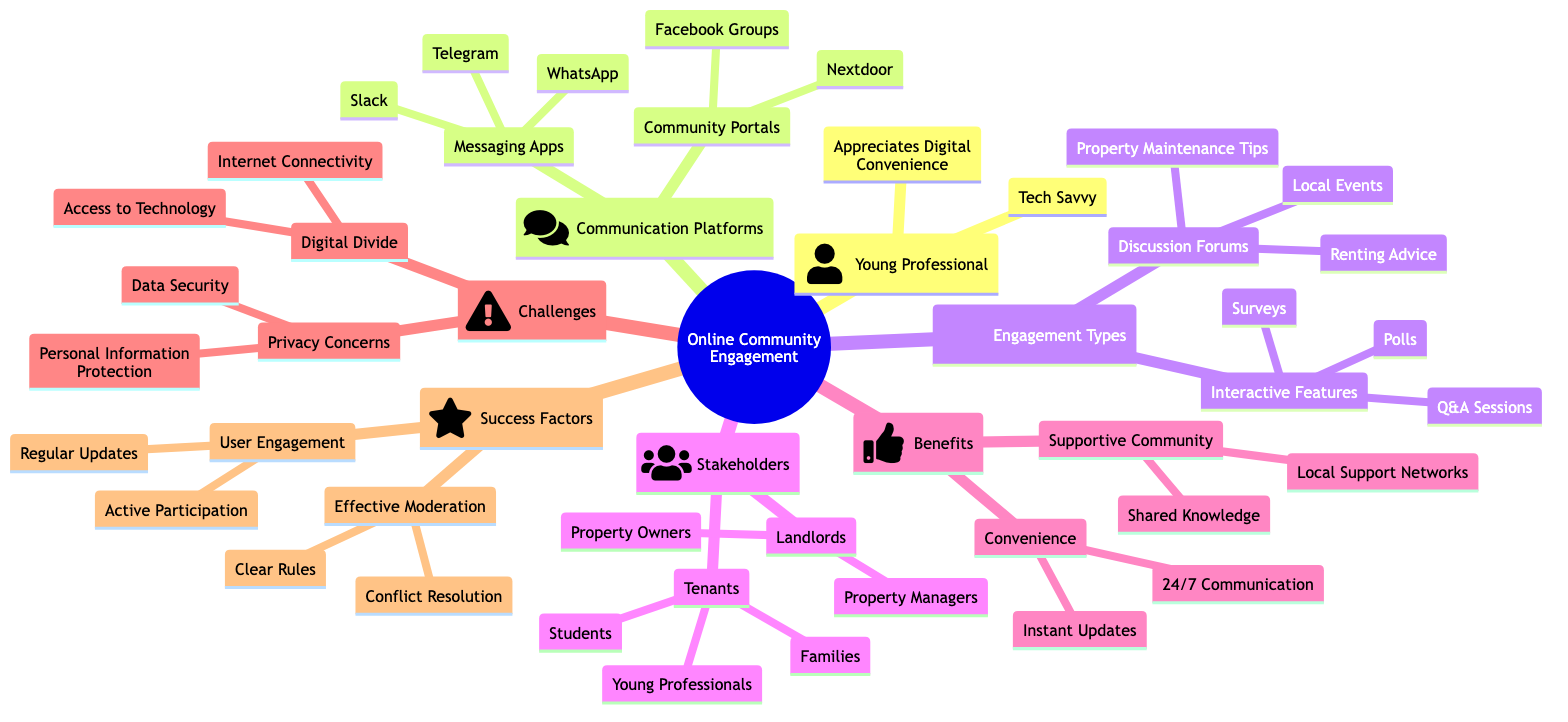What are two messaging apps listed in the communication platforms? The communication platforms node has a sub-node for messaging apps, which includes Slack and WhatsApp as examples.
Answer: Slack, WhatsApp How many stakeholders are identified in the concept map? The stakeholders node contains two main categories: Tenants and Landlords. Counting both of these categories gives a total of two.
Answer: 2 What are two types of interactive features mentioned? Under the engagement types node, specifically within interactive features, the examples listed are polls and surveys.
Answer: Polls, Surveys What is one benefit related to convenience found in the concept map? Within the benefits node, under the convenience sub-node, "24/7 Communication" is mentioned as an example.
Answer: 24/7 Communication What type of engagement is characterized by "Active Participation"? In the success factors section, user engagement includes "Active Participation," indicating it is a specific type of engagement.
Answer: User Engagement What are the two subcategories of tenants identified in the stakeholders section? The stakeholders node indicates a variety of tenant subcategories, specifically listing Young Professionals and Families.
Answer: Young Professionals, Families What privacy concern is tied to the challenges section? In the challenges node, the first listed privacy concern is "Data Security." Hence, this is a specific concern tied to the concept.
Answer: Data Security How many interactive features are listed in the engagement types? The engagement types node lists three interactive features: polls, surveys, and Q&A Sessions. Therefore, the total is three.
Answer: 3 